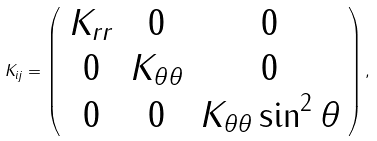Convert formula to latex. <formula><loc_0><loc_0><loc_500><loc_500>K _ { i j } = \left ( \begin{array} { c c c } K _ { r r } & 0 & 0 \\ 0 & K _ { \theta \theta } & 0 \\ 0 & 0 & K _ { \theta \theta } \sin ^ { 2 } \theta \end{array} \right ) ,</formula> 